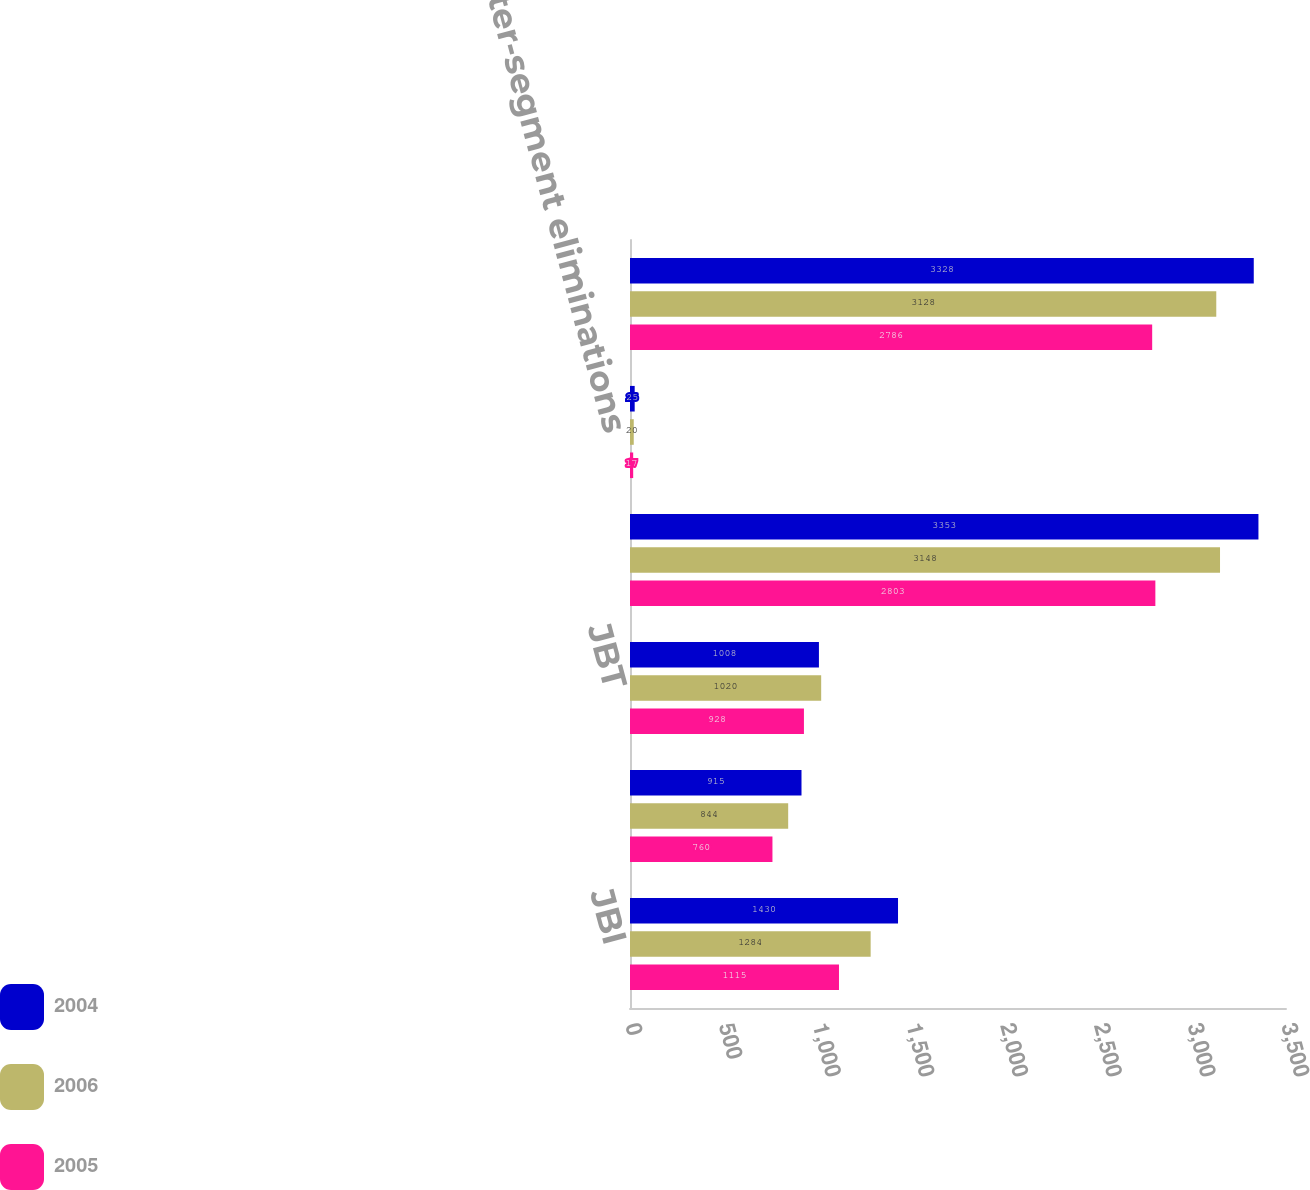Convert chart. <chart><loc_0><loc_0><loc_500><loc_500><stacked_bar_chart><ecel><fcel>JBI<fcel>DCS<fcel>JBT<fcel>Subtotal<fcel>Inter-segment eliminations<fcel>Total<nl><fcel>2004<fcel>1430<fcel>915<fcel>1008<fcel>3353<fcel>25<fcel>3328<nl><fcel>2006<fcel>1284<fcel>844<fcel>1020<fcel>3148<fcel>20<fcel>3128<nl><fcel>2005<fcel>1115<fcel>760<fcel>928<fcel>2803<fcel>17<fcel>2786<nl></chart> 